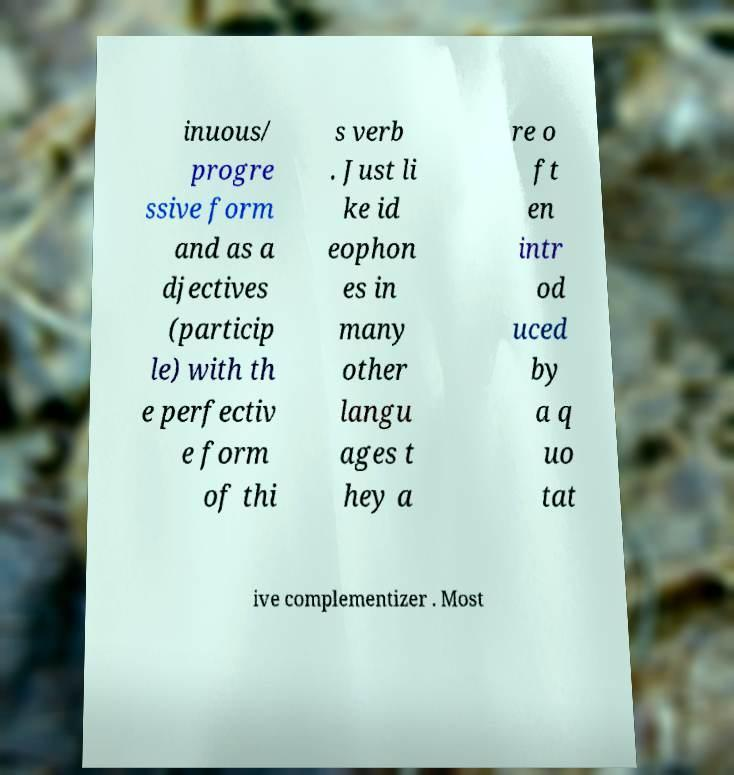Please identify and transcribe the text found in this image. inuous/ progre ssive form and as a djectives (particip le) with th e perfectiv e form of thi s verb . Just li ke id eophon es in many other langu ages t hey a re o ft en intr od uced by a q uo tat ive complementizer . Most 